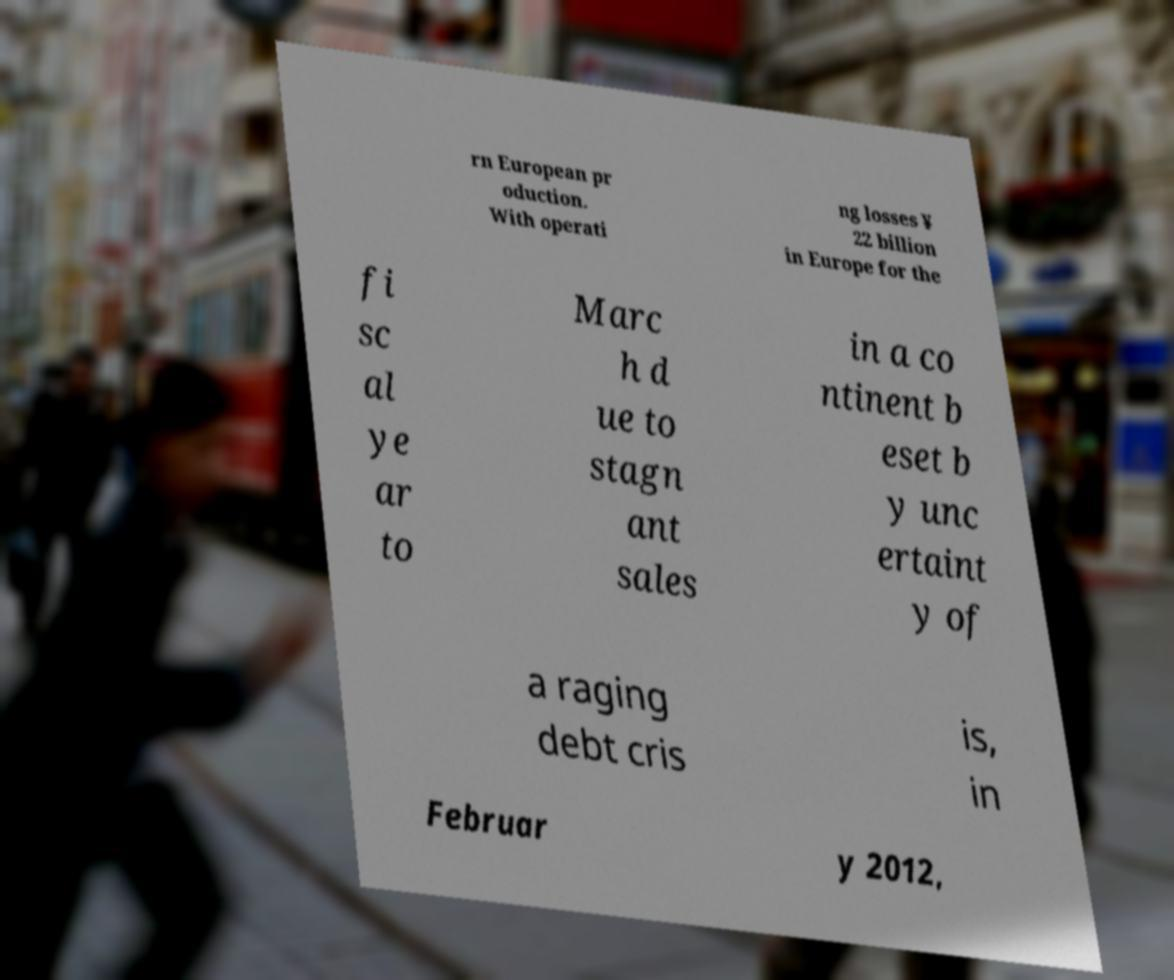Please identify and transcribe the text found in this image. rn European pr oduction. With operati ng losses ¥ 22 billion in Europe for the fi sc al ye ar to Marc h d ue to stagn ant sales in a co ntinent b eset b y unc ertaint y of a raging debt cris is, in Februar y 2012, 